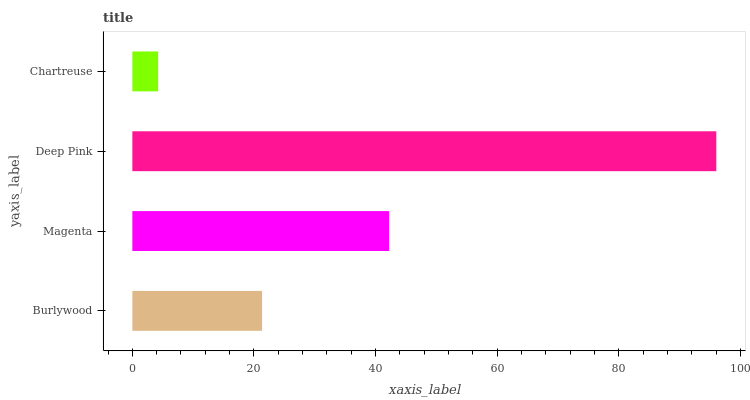Is Chartreuse the minimum?
Answer yes or no. Yes. Is Deep Pink the maximum?
Answer yes or no. Yes. Is Magenta the minimum?
Answer yes or no. No. Is Magenta the maximum?
Answer yes or no. No. Is Magenta greater than Burlywood?
Answer yes or no. Yes. Is Burlywood less than Magenta?
Answer yes or no. Yes. Is Burlywood greater than Magenta?
Answer yes or no. No. Is Magenta less than Burlywood?
Answer yes or no. No. Is Magenta the high median?
Answer yes or no. Yes. Is Burlywood the low median?
Answer yes or no. Yes. Is Burlywood the high median?
Answer yes or no. No. Is Chartreuse the low median?
Answer yes or no. No. 